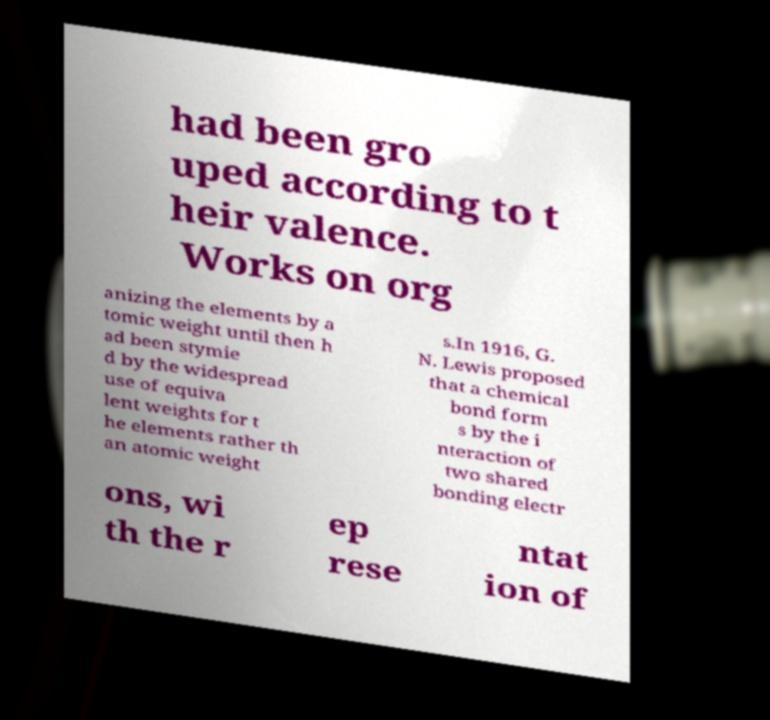Please identify and transcribe the text found in this image. had been gro uped according to t heir valence. Works on org anizing the elements by a tomic weight until then h ad been stymie d by the widespread use of equiva lent weights for t he elements rather th an atomic weight s.In 1916, G. N. Lewis proposed that a chemical bond form s by the i nteraction of two shared bonding electr ons, wi th the r ep rese ntat ion of 